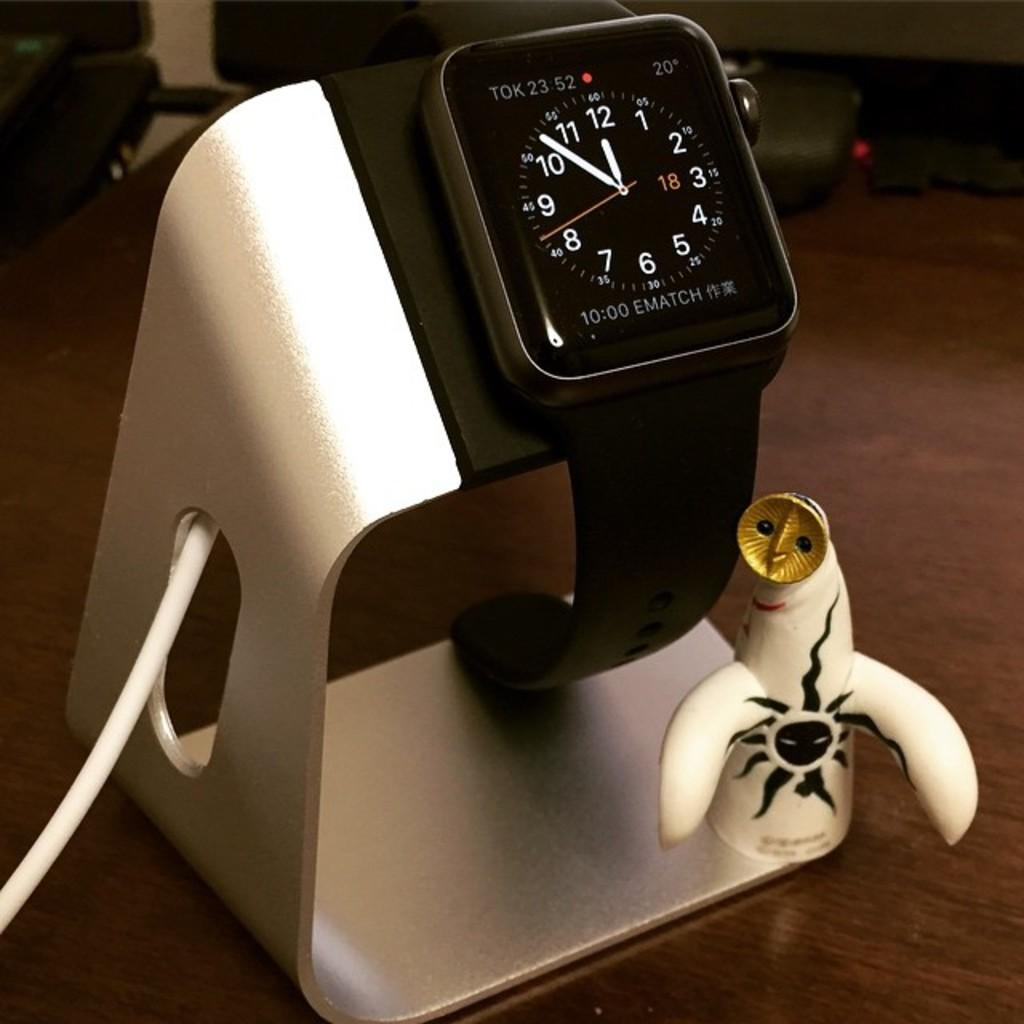<image>
Write a terse but informative summary of the picture. A smartwatch on a silver stand says TOK at the top of the screen. 